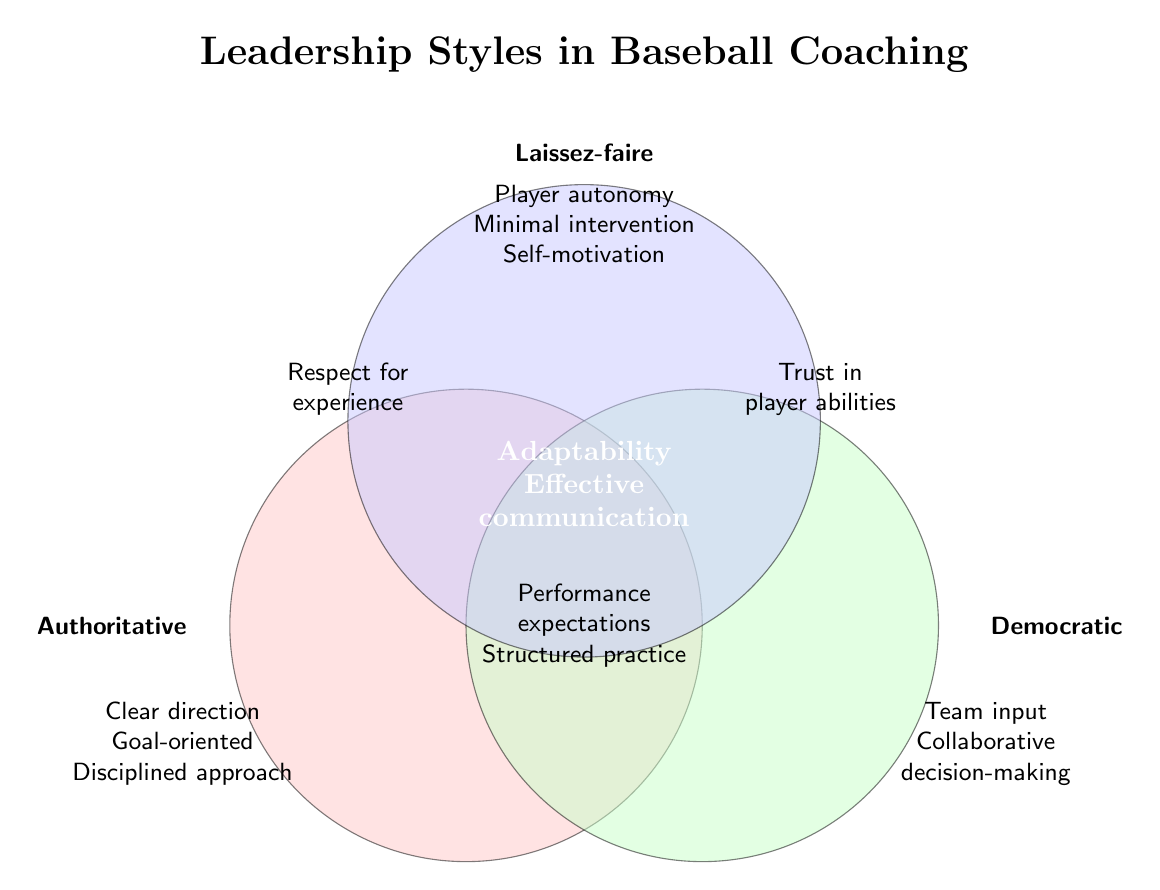What is the title of the figure? The title is located at the top center of the Venn diagram. It provides an overall description of the figure.
Answer: Leadership Styles in Baseball Coaching Which leadership style focuses on "Clear direction"? The Venn diagram labels each section with its associated leadership style. "Clear direction" is listed under the Authoritative section.
Answer: Authoritative How many characteristics are shared by all three leadership styles? The center of the Venn diagram, where all three circles overlap, lists the common characteristics shared by all three styles.
Answer: 2 Which leadership styles emphasize "Trust in player abilities"? The overlapping region between the Democratic and Laissez-faire circles contains "Trust in player abilities".
Answer: Democratic & Laissez-faire Which characteristic is associated with both Authoritative and Laissez-faire styles? The area where the Authoritative and Laissez-faire circles overlap includes "Respect for experience".
Answer: Respect for experience How many characteristics are listed for the Democratic style only? The section labeled as Democratic has three characteristics listed.
Answer: 3 What are the shared characteristics between Authoritative and Democratic leadership styles? The overlap between Authoritative and Democratic circles includes "Performance expectations" and "Structured practice sessions".
Answer: Performance expectations, Structured practice sessions What is the unique focus of the Laissez-faire leadership style? The non-overlapping part of the Laissez-faire circle lists its unique characteristics.
Answer: Player autonomy, Minimal intervention, Self-motivation emphasis Which leadership style includes both "Goal-oriented" and "Disciplined approach"? The Authoritative section includes the characteristics "Goal-oriented" and "Disciplined approach".
Answer: Authoritative List two characteristics shared only by "Authoritative" and "Democratic" leadership styles but not by "Laissez-faire". The overlap between Authoritative and Democratic circles shows their shared characteristics.
Answer: Performance expectations, Structured practice sessions 